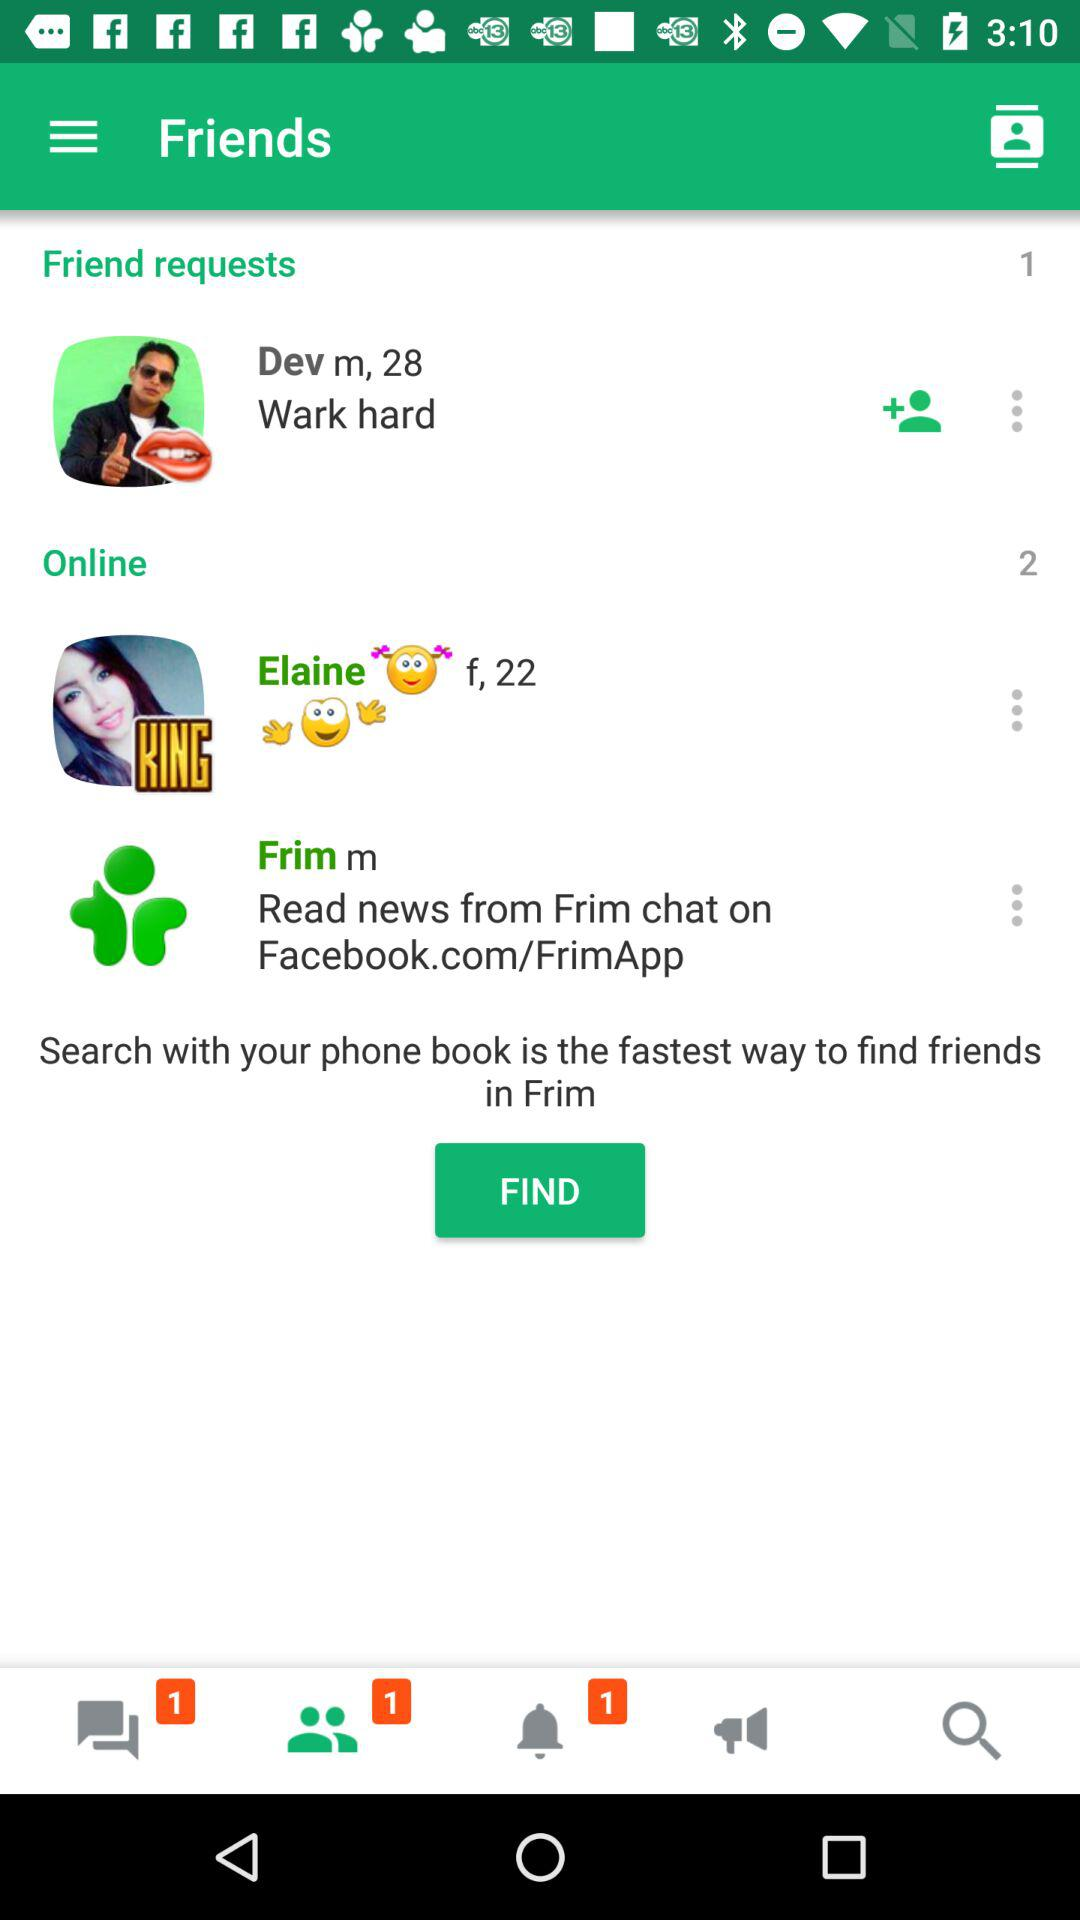How many unread chats are there? There is 1 unread chat. 